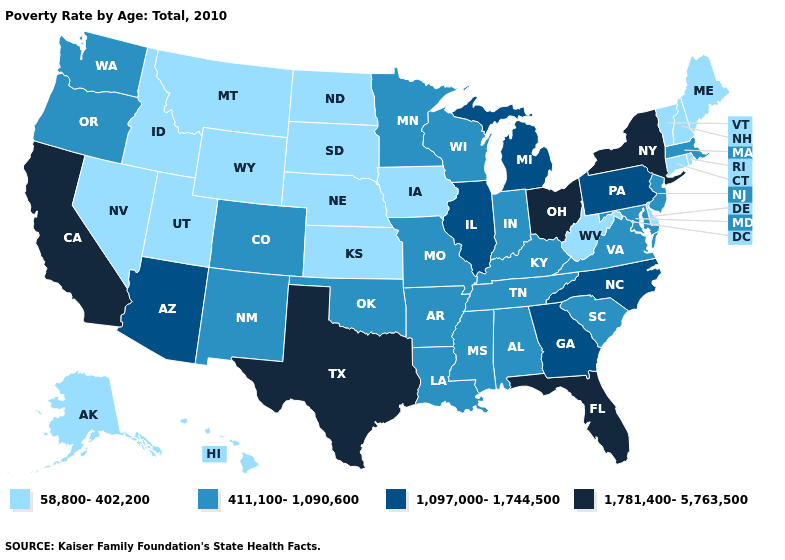What is the value of Wyoming?
Answer briefly. 58,800-402,200. Does California have the highest value in the West?
Write a very short answer. Yes. What is the highest value in the USA?
Answer briefly. 1,781,400-5,763,500. Is the legend a continuous bar?
Be succinct. No. What is the value of Arkansas?
Short answer required. 411,100-1,090,600. Which states hav the highest value in the West?
Quick response, please. California. Does California have a higher value than Washington?
Give a very brief answer. Yes. Among the states that border Iowa , does Nebraska have the lowest value?
Concise answer only. Yes. What is the value of South Dakota?
Quick response, please. 58,800-402,200. Name the states that have a value in the range 411,100-1,090,600?
Concise answer only. Alabama, Arkansas, Colorado, Indiana, Kentucky, Louisiana, Maryland, Massachusetts, Minnesota, Mississippi, Missouri, New Jersey, New Mexico, Oklahoma, Oregon, South Carolina, Tennessee, Virginia, Washington, Wisconsin. What is the value of Maine?
Short answer required. 58,800-402,200. Name the states that have a value in the range 1,097,000-1,744,500?
Quick response, please. Arizona, Georgia, Illinois, Michigan, North Carolina, Pennsylvania. Name the states that have a value in the range 58,800-402,200?
Write a very short answer. Alaska, Connecticut, Delaware, Hawaii, Idaho, Iowa, Kansas, Maine, Montana, Nebraska, Nevada, New Hampshire, North Dakota, Rhode Island, South Dakota, Utah, Vermont, West Virginia, Wyoming. Does New York have the highest value in the USA?
Keep it brief. Yes. What is the lowest value in the USA?
Concise answer only. 58,800-402,200. 